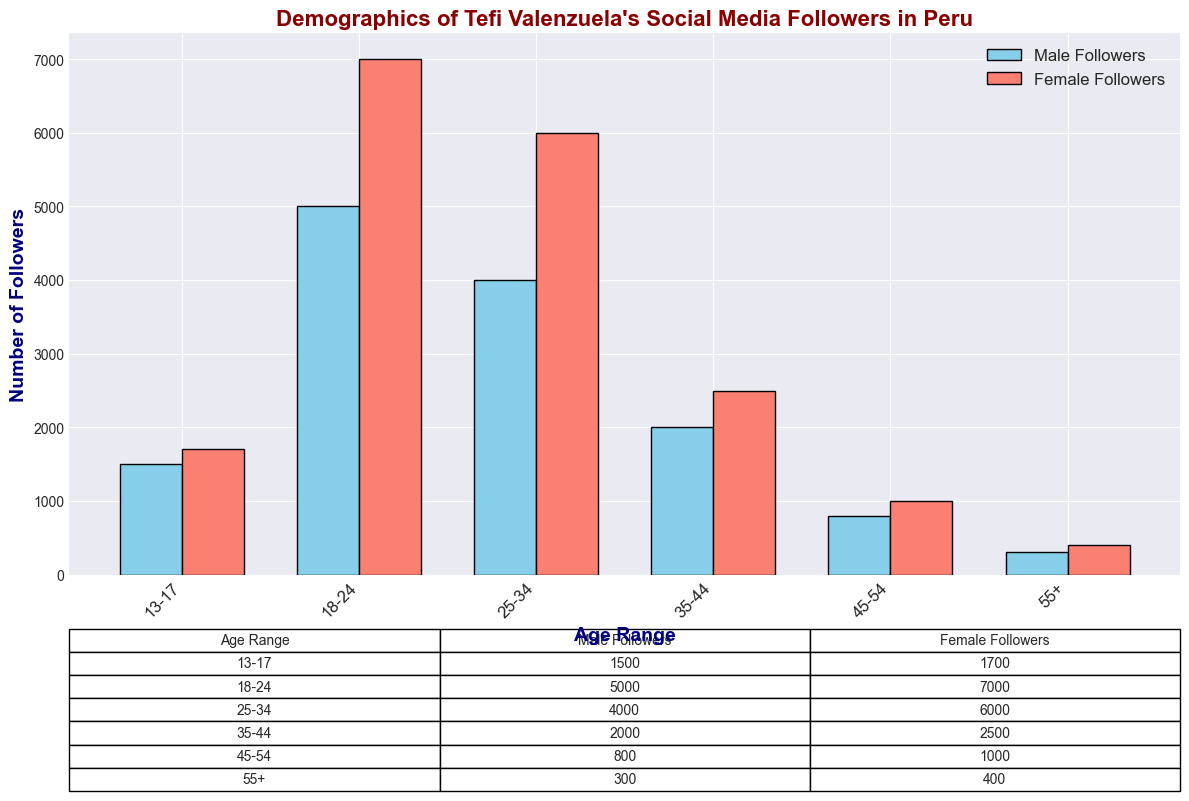What is the total number of followers in the 18-24 age range? To find the total number of followers in the 18-24 age range, sum the male and female followers: 5000 (male) + 7000 (female) = 12000
Answer: 12000 Which gender has more followers in the 25-34 age range? Compare the number of male and female followers in the 25-34 age range: 4000 (male) < 6000 (female), so females have more followers
Answer: Females What is the difference in the number of male and female followers in the 13-17 age range? Subtract the number of male followers in the 13-17 age range from the number of female followers: 1700 (female) - 1500 (male) = 200
Answer: 200 In which age range is the number of female followers exactly 1.5 times the number of male followers? Look through the age ranges to find where female followers are 1.5 times more than male followers. The relationship is true for the 45-54 age range: 1000 (female) = 1.5 * 800 (male)
Answer: 45-54 Which age range has the highest number of male followers? By comparing the heights of the bars representing male followers, the age range with the highest number of male followers is 18-24
Answer: 18-24 What is the average number of followers in the 35-44 age range? Find the average by summing the male and female followers and then dividing by 2: (2000 male + 2500 female) / 2 = 2250
Answer: 2250 Which age range has the lowest total number of followers? Look for the age range with the shortest combined bars. The shortest combined bars are in the 55+ age range: 300 (male) + 400 (female) = 700
Answer: 55+ By how much do female followers exceed male followers in the 18-24 age range? Subtract the number of male followers from the number of female followers in the 18-24 age range: 7000 (female) - 5000 (male) = 2000
Answer: 2000 Is the number of male followers greater than the number of female followers in any age range? By comparing the bars representing male and female followers in all age ranges, it's clear that female followers always outnumber male followers in every age range
Answer: No What is the total number of followers in the 35-44 and 45-54 age ranges combined? Sum the total number of followers in the specified age ranges: (2000 male + 2500 female) + (800 male + 1000 female) = 4500 + 1800 = 6300
Answer: 6300 